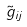<formula> <loc_0><loc_0><loc_500><loc_500>\tilde { g } _ { i j }</formula> 